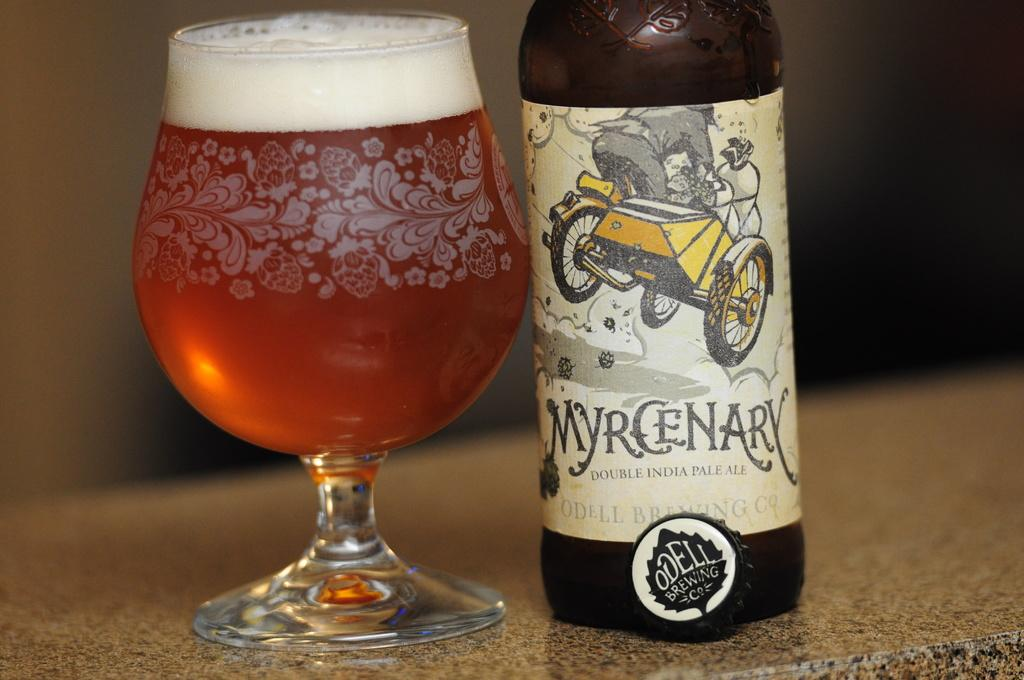<image>
Describe the image concisely. A bottle of Myrcenary double india pale ale next to a full glass. 